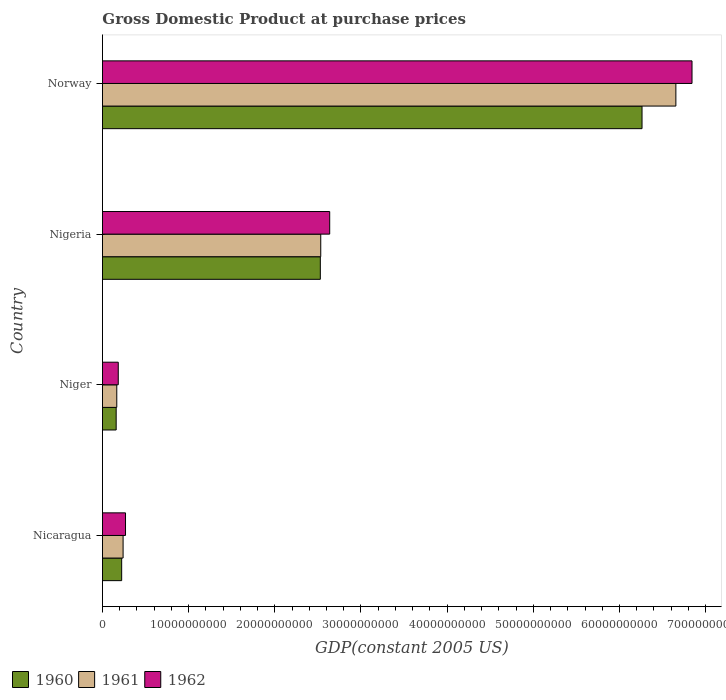How many groups of bars are there?
Offer a terse response. 4. How many bars are there on the 3rd tick from the bottom?
Provide a short and direct response. 3. What is the label of the 2nd group of bars from the top?
Offer a terse response. Nigeria. In how many cases, is the number of bars for a given country not equal to the number of legend labels?
Offer a very short reply. 0. What is the GDP at purchase prices in 1962 in Nicaragua?
Your response must be concise. 2.67e+09. Across all countries, what is the maximum GDP at purchase prices in 1962?
Give a very brief answer. 6.84e+1. Across all countries, what is the minimum GDP at purchase prices in 1962?
Ensure brevity in your answer.  1.83e+09. In which country was the GDP at purchase prices in 1960 minimum?
Give a very brief answer. Niger. What is the total GDP at purchase prices in 1960 in the graph?
Your response must be concise. 9.17e+1. What is the difference between the GDP at purchase prices in 1962 in Nicaragua and that in Norway?
Your answer should be compact. -6.57e+1. What is the difference between the GDP at purchase prices in 1962 in Nicaragua and the GDP at purchase prices in 1960 in Niger?
Your answer should be very brief. 1.08e+09. What is the average GDP at purchase prices in 1960 per country?
Provide a short and direct response. 2.29e+1. What is the difference between the GDP at purchase prices in 1961 and GDP at purchase prices in 1962 in Niger?
Ensure brevity in your answer.  -1.71e+08. What is the ratio of the GDP at purchase prices in 1961 in Niger to that in Norway?
Provide a succinct answer. 0.02. Is the difference between the GDP at purchase prices in 1961 in Nicaragua and Nigeria greater than the difference between the GDP at purchase prices in 1962 in Nicaragua and Nigeria?
Offer a terse response. Yes. What is the difference between the highest and the second highest GDP at purchase prices in 1961?
Ensure brevity in your answer.  4.12e+1. What is the difference between the highest and the lowest GDP at purchase prices in 1961?
Offer a terse response. 6.49e+1. Is the sum of the GDP at purchase prices in 1960 in Nigeria and Norway greater than the maximum GDP at purchase prices in 1962 across all countries?
Give a very brief answer. Yes. What does the 2nd bar from the bottom in Nigeria represents?
Give a very brief answer. 1961. How many bars are there?
Ensure brevity in your answer.  12. Are all the bars in the graph horizontal?
Offer a terse response. Yes. What is the difference between two consecutive major ticks on the X-axis?
Offer a very short reply. 1.00e+1. Where does the legend appear in the graph?
Provide a succinct answer. Bottom left. How many legend labels are there?
Offer a terse response. 3. What is the title of the graph?
Ensure brevity in your answer.  Gross Domestic Product at purchase prices. Does "1969" appear as one of the legend labels in the graph?
Keep it short and to the point. No. What is the label or title of the X-axis?
Keep it short and to the point. GDP(constant 2005 US). What is the GDP(constant 2005 US) in 1960 in Nicaragua?
Your answer should be very brief. 2.23e+09. What is the GDP(constant 2005 US) of 1961 in Nicaragua?
Provide a succinct answer. 2.39e+09. What is the GDP(constant 2005 US) of 1962 in Nicaragua?
Keep it short and to the point. 2.67e+09. What is the GDP(constant 2005 US) in 1960 in Niger?
Provide a short and direct response. 1.59e+09. What is the GDP(constant 2005 US) in 1961 in Niger?
Give a very brief answer. 1.66e+09. What is the GDP(constant 2005 US) of 1962 in Niger?
Offer a very short reply. 1.83e+09. What is the GDP(constant 2005 US) in 1960 in Nigeria?
Offer a terse response. 2.53e+1. What is the GDP(constant 2005 US) in 1961 in Nigeria?
Offer a terse response. 2.53e+1. What is the GDP(constant 2005 US) in 1962 in Nigeria?
Your response must be concise. 2.64e+1. What is the GDP(constant 2005 US) in 1960 in Norway?
Offer a terse response. 6.26e+1. What is the GDP(constant 2005 US) of 1961 in Norway?
Your answer should be compact. 6.65e+1. What is the GDP(constant 2005 US) in 1962 in Norway?
Your answer should be very brief. 6.84e+1. Across all countries, what is the maximum GDP(constant 2005 US) of 1960?
Offer a very short reply. 6.26e+1. Across all countries, what is the maximum GDP(constant 2005 US) in 1961?
Give a very brief answer. 6.65e+1. Across all countries, what is the maximum GDP(constant 2005 US) in 1962?
Your response must be concise. 6.84e+1. Across all countries, what is the minimum GDP(constant 2005 US) of 1960?
Provide a succinct answer. 1.59e+09. Across all countries, what is the minimum GDP(constant 2005 US) of 1961?
Provide a short and direct response. 1.66e+09. Across all countries, what is the minimum GDP(constant 2005 US) in 1962?
Offer a terse response. 1.83e+09. What is the total GDP(constant 2005 US) in 1960 in the graph?
Make the answer very short. 9.17e+1. What is the total GDP(constant 2005 US) in 1961 in the graph?
Provide a succinct answer. 9.59e+1. What is the total GDP(constant 2005 US) in 1962 in the graph?
Your answer should be compact. 9.93e+1. What is the difference between the GDP(constant 2005 US) in 1960 in Nicaragua and that in Niger?
Provide a succinct answer. 6.39e+08. What is the difference between the GDP(constant 2005 US) of 1961 in Nicaragua and that in Niger?
Keep it short and to the point. 7.32e+08. What is the difference between the GDP(constant 2005 US) of 1962 in Nicaragua and that in Niger?
Your answer should be very brief. 8.41e+08. What is the difference between the GDP(constant 2005 US) in 1960 in Nicaragua and that in Nigeria?
Your answer should be compact. -2.31e+1. What is the difference between the GDP(constant 2005 US) in 1961 in Nicaragua and that in Nigeria?
Your answer should be compact. -2.29e+1. What is the difference between the GDP(constant 2005 US) of 1962 in Nicaragua and that in Nigeria?
Your answer should be very brief. -2.37e+1. What is the difference between the GDP(constant 2005 US) of 1960 in Nicaragua and that in Norway?
Provide a short and direct response. -6.04e+1. What is the difference between the GDP(constant 2005 US) of 1961 in Nicaragua and that in Norway?
Give a very brief answer. -6.41e+1. What is the difference between the GDP(constant 2005 US) in 1962 in Nicaragua and that in Norway?
Ensure brevity in your answer.  -6.57e+1. What is the difference between the GDP(constant 2005 US) of 1960 in Niger and that in Nigeria?
Your answer should be very brief. -2.37e+1. What is the difference between the GDP(constant 2005 US) of 1961 in Niger and that in Nigeria?
Offer a very short reply. -2.37e+1. What is the difference between the GDP(constant 2005 US) of 1962 in Niger and that in Nigeria?
Give a very brief answer. -2.45e+1. What is the difference between the GDP(constant 2005 US) in 1960 in Niger and that in Norway?
Make the answer very short. -6.10e+1. What is the difference between the GDP(constant 2005 US) of 1961 in Niger and that in Norway?
Your answer should be very brief. -6.49e+1. What is the difference between the GDP(constant 2005 US) of 1962 in Niger and that in Norway?
Give a very brief answer. -6.66e+1. What is the difference between the GDP(constant 2005 US) in 1960 in Nigeria and that in Norway?
Make the answer very short. -3.73e+1. What is the difference between the GDP(constant 2005 US) in 1961 in Nigeria and that in Norway?
Provide a succinct answer. -4.12e+1. What is the difference between the GDP(constant 2005 US) of 1962 in Nigeria and that in Norway?
Your answer should be very brief. -4.20e+1. What is the difference between the GDP(constant 2005 US) of 1960 in Nicaragua and the GDP(constant 2005 US) of 1961 in Niger?
Your answer should be very brief. 5.67e+08. What is the difference between the GDP(constant 2005 US) in 1960 in Nicaragua and the GDP(constant 2005 US) in 1962 in Niger?
Make the answer very short. 3.96e+08. What is the difference between the GDP(constant 2005 US) of 1961 in Nicaragua and the GDP(constant 2005 US) of 1962 in Niger?
Keep it short and to the point. 5.61e+08. What is the difference between the GDP(constant 2005 US) in 1960 in Nicaragua and the GDP(constant 2005 US) in 1961 in Nigeria?
Offer a very short reply. -2.31e+1. What is the difference between the GDP(constant 2005 US) in 1960 in Nicaragua and the GDP(constant 2005 US) in 1962 in Nigeria?
Offer a very short reply. -2.41e+1. What is the difference between the GDP(constant 2005 US) of 1961 in Nicaragua and the GDP(constant 2005 US) of 1962 in Nigeria?
Keep it short and to the point. -2.40e+1. What is the difference between the GDP(constant 2005 US) of 1960 in Nicaragua and the GDP(constant 2005 US) of 1961 in Norway?
Provide a short and direct response. -6.43e+1. What is the difference between the GDP(constant 2005 US) in 1960 in Nicaragua and the GDP(constant 2005 US) in 1962 in Norway?
Make the answer very short. -6.62e+1. What is the difference between the GDP(constant 2005 US) in 1961 in Nicaragua and the GDP(constant 2005 US) in 1962 in Norway?
Give a very brief answer. -6.60e+1. What is the difference between the GDP(constant 2005 US) of 1960 in Niger and the GDP(constant 2005 US) of 1961 in Nigeria?
Make the answer very short. -2.37e+1. What is the difference between the GDP(constant 2005 US) of 1960 in Niger and the GDP(constant 2005 US) of 1962 in Nigeria?
Give a very brief answer. -2.48e+1. What is the difference between the GDP(constant 2005 US) in 1961 in Niger and the GDP(constant 2005 US) in 1962 in Nigeria?
Offer a terse response. -2.47e+1. What is the difference between the GDP(constant 2005 US) in 1960 in Niger and the GDP(constant 2005 US) in 1961 in Norway?
Offer a terse response. -6.50e+1. What is the difference between the GDP(constant 2005 US) in 1960 in Niger and the GDP(constant 2005 US) in 1962 in Norway?
Provide a short and direct response. -6.68e+1. What is the difference between the GDP(constant 2005 US) of 1961 in Niger and the GDP(constant 2005 US) of 1962 in Norway?
Ensure brevity in your answer.  -6.68e+1. What is the difference between the GDP(constant 2005 US) of 1960 in Nigeria and the GDP(constant 2005 US) of 1961 in Norway?
Ensure brevity in your answer.  -4.13e+1. What is the difference between the GDP(constant 2005 US) in 1960 in Nigeria and the GDP(constant 2005 US) in 1962 in Norway?
Offer a terse response. -4.31e+1. What is the difference between the GDP(constant 2005 US) in 1961 in Nigeria and the GDP(constant 2005 US) in 1962 in Norway?
Your response must be concise. -4.31e+1. What is the average GDP(constant 2005 US) of 1960 per country?
Your answer should be very brief. 2.29e+1. What is the average GDP(constant 2005 US) of 1961 per country?
Provide a succinct answer. 2.40e+1. What is the average GDP(constant 2005 US) of 1962 per country?
Give a very brief answer. 2.48e+1. What is the difference between the GDP(constant 2005 US) of 1960 and GDP(constant 2005 US) of 1961 in Nicaragua?
Your answer should be very brief. -1.65e+08. What is the difference between the GDP(constant 2005 US) of 1960 and GDP(constant 2005 US) of 1962 in Nicaragua?
Your response must be concise. -4.45e+08. What is the difference between the GDP(constant 2005 US) of 1961 and GDP(constant 2005 US) of 1962 in Nicaragua?
Your answer should be very brief. -2.80e+08. What is the difference between the GDP(constant 2005 US) of 1960 and GDP(constant 2005 US) of 1961 in Niger?
Your response must be concise. -7.23e+07. What is the difference between the GDP(constant 2005 US) of 1960 and GDP(constant 2005 US) of 1962 in Niger?
Your response must be concise. -2.43e+08. What is the difference between the GDP(constant 2005 US) in 1961 and GDP(constant 2005 US) in 1962 in Niger?
Your answer should be compact. -1.71e+08. What is the difference between the GDP(constant 2005 US) of 1960 and GDP(constant 2005 US) of 1961 in Nigeria?
Provide a short and direct response. -4.85e+07. What is the difference between the GDP(constant 2005 US) in 1960 and GDP(constant 2005 US) in 1962 in Nigeria?
Your answer should be compact. -1.09e+09. What is the difference between the GDP(constant 2005 US) of 1961 and GDP(constant 2005 US) of 1962 in Nigeria?
Your response must be concise. -1.04e+09. What is the difference between the GDP(constant 2005 US) in 1960 and GDP(constant 2005 US) in 1961 in Norway?
Offer a terse response. -3.93e+09. What is the difference between the GDP(constant 2005 US) of 1960 and GDP(constant 2005 US) of 1962 in Norway?
Give a very brief answer. -5.80e+09. What is the difference between the GDP(constant 2005 US) of 1961 and GDP(constant 2005 US) of 1962 in Norway?
Your answer should be compact. -1.87e+09. What is the ratio of the GDP(constant 2005 US) in 1960 in Nicaragua to that in Niger?
Ensure brevity in your answer.  1.4. What is the ratio of the GDP(constant 2005 US) of 1961 in Nicaragua to that in Niger?
Provide a short and direct response. 1.44. What is the ratio of the GDP(constant 2005 US) of 1962 in Nicaragua to that in Niger?
Ensure brevity in your answer.  1.46. What is the ratio of the GDP(constant 2005 US) of 1960 in Nicaragua to that in Nigeria?
Keep it short and to the point. 0.09. What is the ratio of the GDP(constant 2005 US) of 1961 in Nicaragua to that in Nigeria?
Keep it short and to the point. 0.09. What is the ratio of the GDP(constant 2005 US) of 1962 in Nicaragua to that in Nigeria?
Provide a succinct answer. 0.1. What is the ratio of the GDP(constant 2005 US) in 1960 in Nicaragua to that in Norway?
Provide a short and direct response. 0.04. What is the ratio of the GDP(constant 2005 US) of 1961 in Nicaragua to that in Norway?
Offer a very short reply. 0.04. What is the ratio of the GDP(constant 2005 US) of 1962 in Nicaragua to that in Norway?
Offer a very short reply. 0.04. What is the ratio of the GDP(constant 2005 US) of 1960 in Niger to that in Nigeria?
Keep it short and to the point. 0.06. What is the ratio of the GDP(constant 2005 US) of 1961 in Niger to that in Nigeria?
Give a very brief answer. 0.07. What is the ratio of the GDP(constant 2005 US) in 1962 in Niger to that in Nigeria?
Offer a terse response. 0.07. What is the ratio of the GDP(constant 2005 US) in 1960 in Niger to that in Norway?
Your response must be concise. 0.03. What is the ratio of the GDP(constant 2005 US) in 1961 in Niger to that in Norway?
Your answer should be very brief. 0.03. What is the ratio of the GDP(constant 2005 US) in 1962 in Niger to that in Norway?
Offer a terse response. 0.03. What is the ratio of the GDP(constant 2005 US) of 1960 in Nigeria to that in Norway?
Make the answer very short. 0.4. What is the ratio of the GDP(constant 2005 US) of 1961 in Nigeria to that in Norway?
Provide a short and direct response. 0.38. What is the ratio of the GDP(constant 2005 US) in 1962 in Nigeria to that in Norway?
Make the answer very short. 0.39. What is the difference between the highest and the second highest GDP(constant 2005 US) of 1960?
Provide a succinct answer. 3.73e+1. What is the difference between the highest and the second highest GDP(constant 2005 US) in 1961?
Your answer should be very brief. 4.12e+1. What is the difference between the highest and the second highest GDP(constant 2005 US) in 1962?
Your answer should be very brief. 4.20e+1. What is the difference between the highest and the lowest GDP(constant 2005 US) in 1960?
Make the answer very short. 6.10e+1. What is the difference between the highest and the lowest GDP(constant 2005 US) in 1961?
Your answer should be compact. 6.49e+1. What is the difference between the highest and the lowest GDP(constant 2005 US) in 1962?
Your answer should be compact. 6.66e+1. 